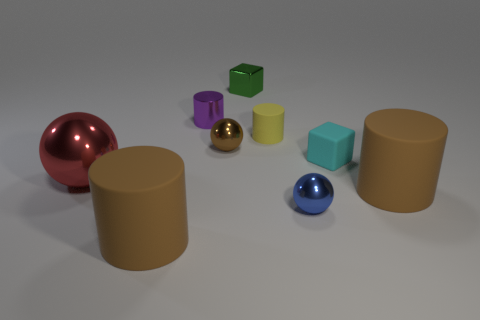Is there any pattern to the arrangement of objects? There doesn't seem to be a specific pattern to the arrangement of the objects in terms of color, size, or shape. The objects are scattered seemingly at random on a flat surface. Could you guess what the purpose of this image could be? The image appears to be a setup for either a visual study of geometric shapes, colors, and textures, or perhaps a demonstration of three-dimensional rendering techniques. It can also be used as an educational tool to teach about different geometric forms and color identification. 